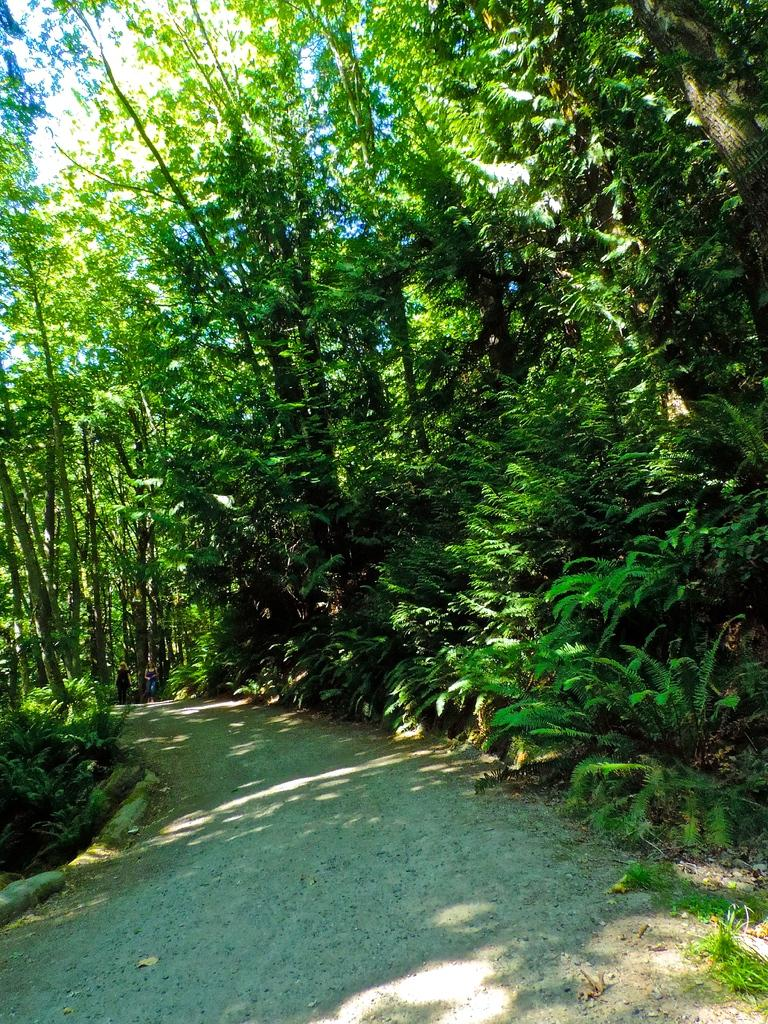What can be seen in the image that people might walk on? There is a pathway in the image that people might walk on. What type of natural elements are present near the pathway? Plants and trees are near the pathway in the image. How many people are visible on the pathway? Two people are standing on the pathway in the image. Can you tell me how many copies of the monkey are present in the image? There are no monkeys present in the image, so there are no copies to count. 